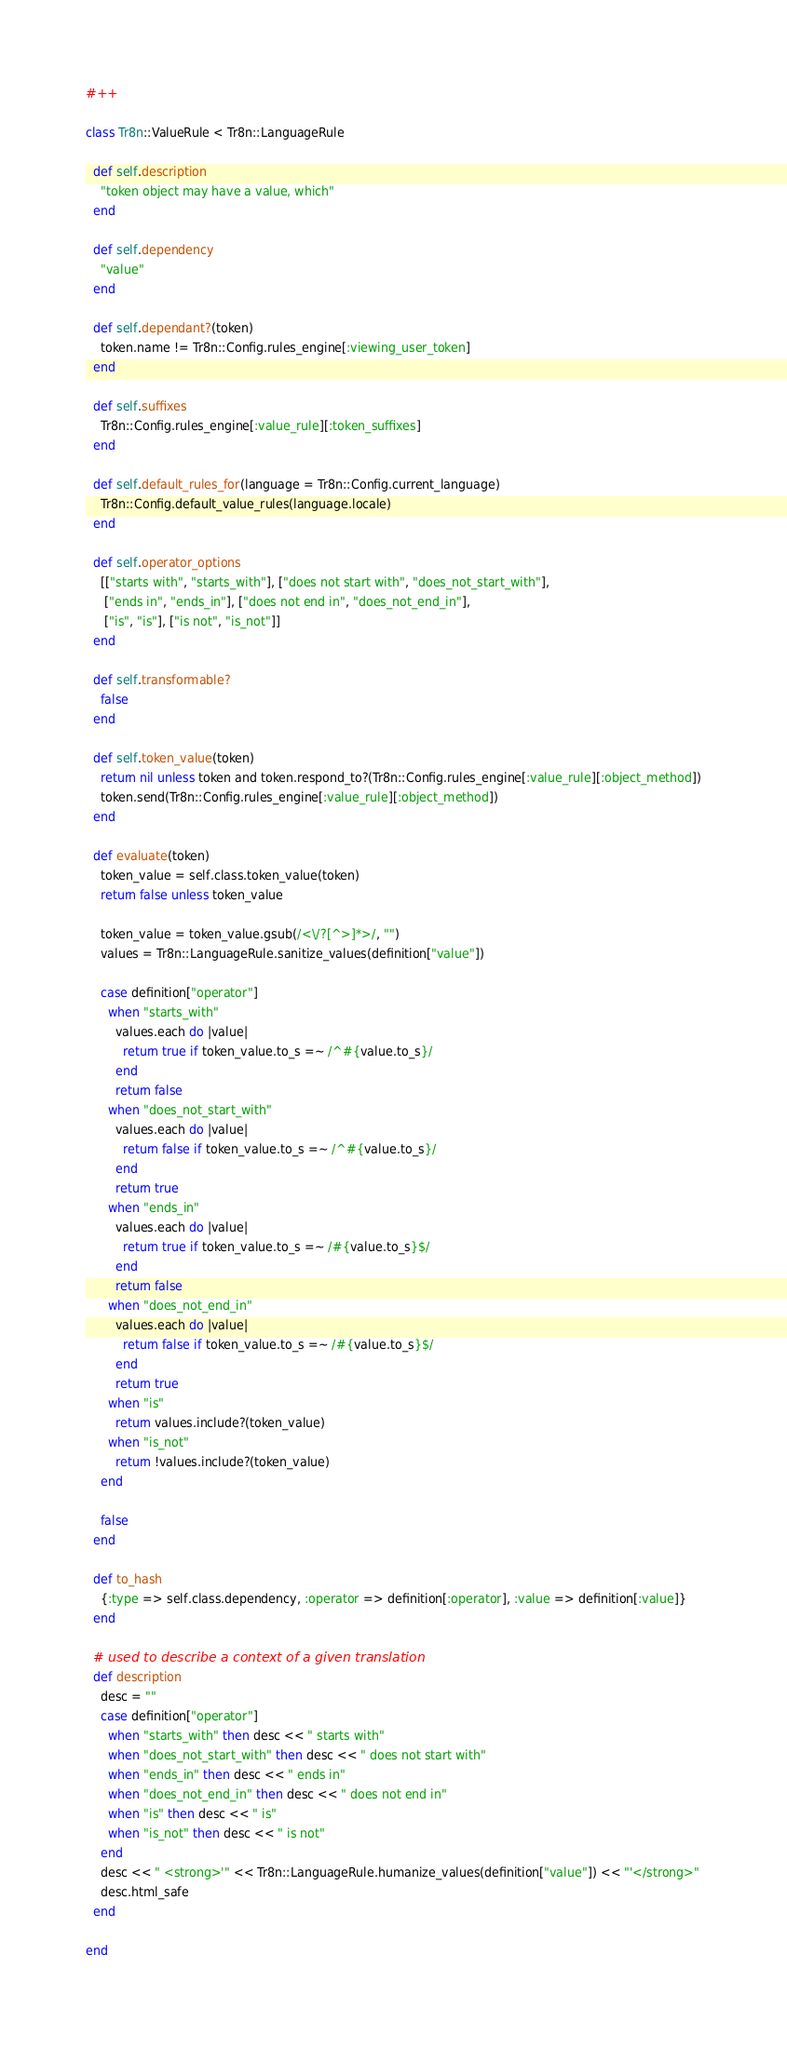Convert code to text. <code><loc_0><loc_0><loc_500><loc_500><_Ruby_>#++

class Tr8n::ValueRule < Tr8n::LanguageRule
  
  def self.description
    "token object may have a value, which"
  end
  
  def self.dependency
    "value" 
  end
  
  def self.dependant?(token)
    token.name != Tr8n::Config.rules_engine[:viewing_user_token]
  end

  def self.suffixes
    Tr8n::Config.rules_engine[:value_rule][:token_suffixes]
  end

  def self.default_rules_for(language = Tr8n::Config.current_language)
    Tr8n::Config.default_value_rules(language.locale)
  end
  
  def self.operator_options
    [["starts with", "starts_with"], ["does not start with", "does_not_start_with"], 
     ["ends in", "ends_in"], ["does not end in", "does_not_end_in"],
     ["is", "is"], ["is not", "is_not"]]
  end

  def self.transformable?
    false
  end

  def self.token_value(token)
    return nil unless token and token.respond_to?(Tr8n::Config.rules_engine[:value_rule][:object_method])
    token.send(Tr8n::Config.rules_engine[:value_rule][:object_method])
  end

  def evaluate(token)
    token_value = self.class.token_value(token)
    return false unless token_value

    token_value = token_value.gsub(/<\/?[^>]*>/, "")
    values = Tr8n::LanguageRule.sanitize_values(definition["value"])
    
    case definition["operator"]
      when "starts_with" 
        values.each do |value|
          return true if token_value.to_s =~ /^#{value.to_s}/  
        end
        return false
      when "does_not_start_with"         
        values.each do |value|
          return false if token_value.to_s =~ /^#{value.to_s}/  
        end
        return true
      when "ends_in"
        values.each do |value|
          return true if token_value.to_s =~ /#{value.to_s}$/  
        end
        return false
      when "does_not_end_in"         
        values.each do |value|
          return false if token_value.to_s =~ /#{value.to_s}$/  
        end
        return true
      when "is"         
        return values.include?(token_value)
      when "is_not"        
        return !values.include?(token_value)
    end
    
    false
  end

  def to_hash
    {:type => self.class.dependency, :operator => definition[:operator], :value => definition[:value]}
  end

  # used to describe a context of a given translation
  def description
    desc = ""
    case definition["operator"]
      when "starts_with" then desc << " starts with"
      when "does_not_start_with" then desc << " does not start with"        
      when "ends_in" then desc << " ends in"        
      when "does_not_end_in" then desc << " does not end in"        
      when "is" then desc << " is"        
      when "is_not" then desc << " is not"        
    end
    desc << " <strong>'" << Tr8n::LanguageRule.humanize_values(definition["value"]) << "'</strong>"
    desc.html_safe
  end

end
</code> 